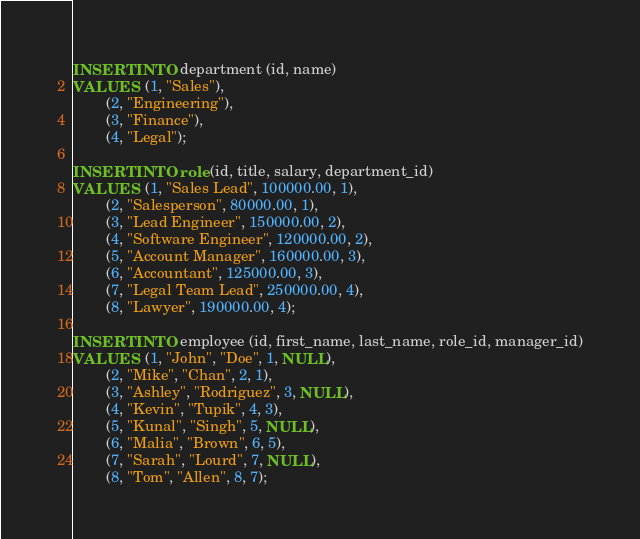Convert code to text. <code><loc_0><loc_0><loc_500><loc_500><_SQL_>INSERT INTO department (id, name)
VALUES  (1, "Sales"),
        (2, "Engineering"),
        (3, "Finance"),
        (4, "Legal");

INSERT INTO role (id, title, salary, department_id)
VALUES  (1, "Sales Lead", 100000.00, 1),
        (2, "Salesperson", 80000.00, 1),
        (3, "Lead Engineer", 150000.00, 2),
        (4, "Software Engineer", 120000.00, 2),
        (5, "Account Manager", 160000.00, 3),
        (6, "Accountant", 125000.00, 3),
        (7, "Legal Team Lead", 250000.00, 4),
        (8, "Lawyer", 190000.00, 4);

INSERT INTO employee (id, first_name, last_name, role_id, manager_id)
VALUES  (1, "John", "Doe", 1, NULL),
        (2, "Mike", "Chan", 2, 1),
        (3, "Ashley", "Rodriguez", 3, NULL),
        (4, "Kevin", "Tupik", 4, 3),
        (5, "Kunal", "Singh", 5, NULL),
        (6, "Malia", "Brown", 6, 5),
        (7, "Sarah", "Lourd", 7, NULL),
        (8, "Tom", "Allen", 8, 7);</code> 